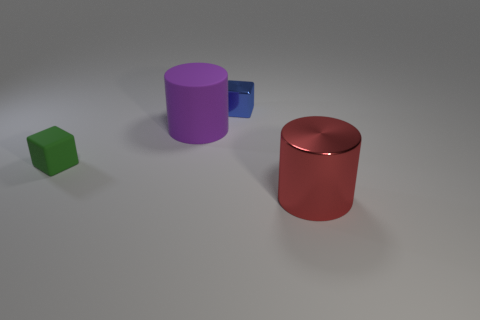Add 4 red metal things. How many objects exist? 8 Add 1 purple matte objects. How many purple matte objects are left? 2 Add 2 large matte cylinders. How many large matte cylinders exist? 3 Subtract 1 green cubes. How many objects are left? 3 Subtract all big red metal things. Subtract all small cubes. How many objects are left? 1 